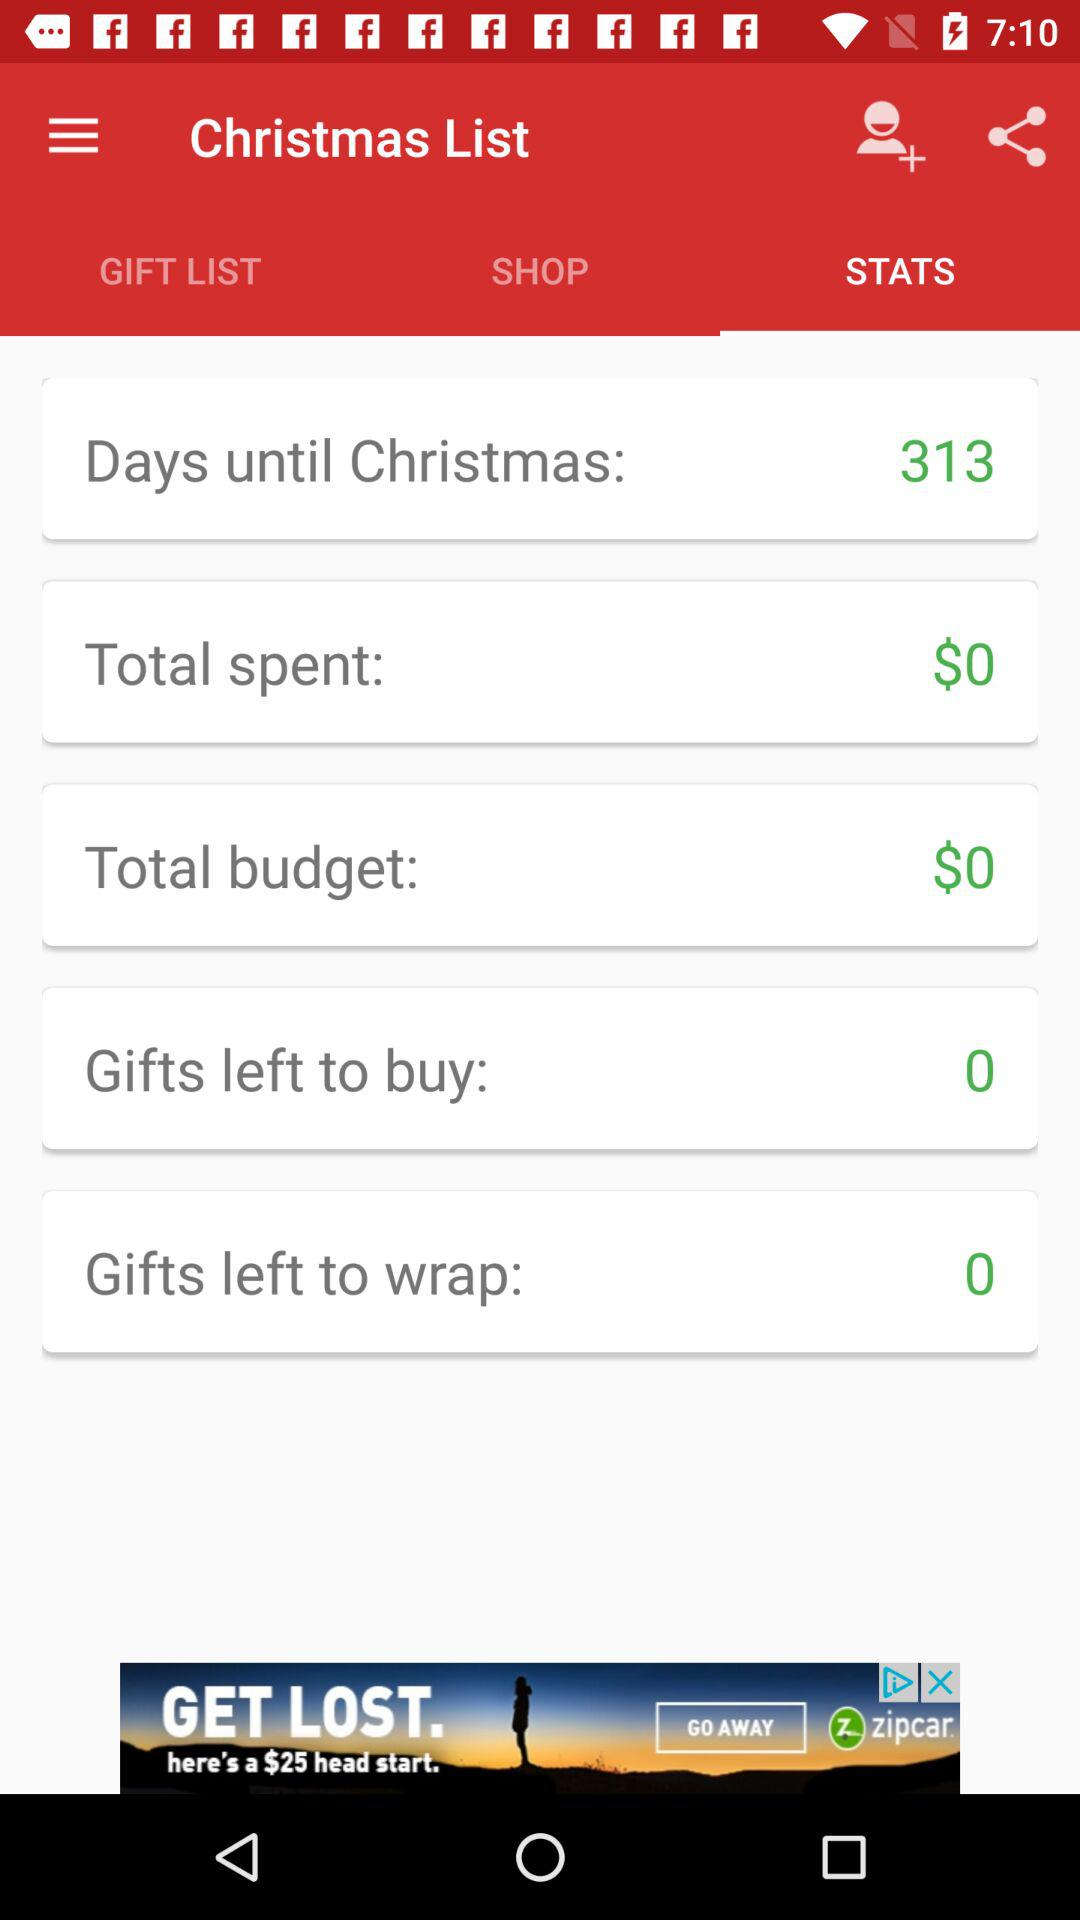How many gifts are left to buy? There are 0 gifts left to buy. 